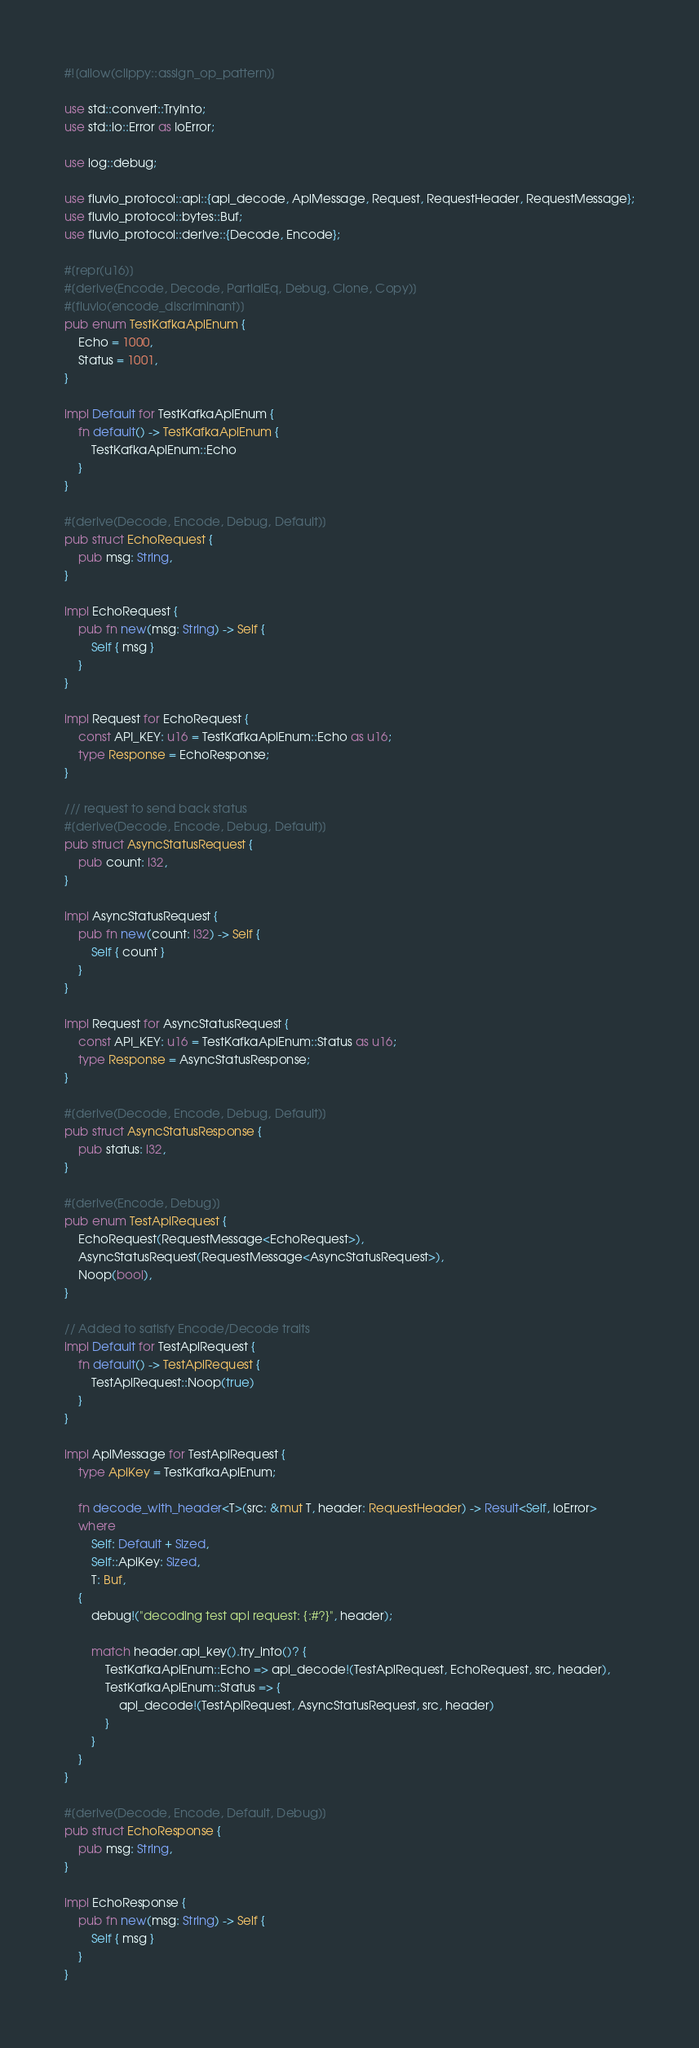Convert code to text. <code><loc_0><loc_0><loc_500><loc_500><_Rust_>#![allow(clippy::assign_op_pattern)]

use std::convert::TryInto;
use std::io::Error as IoError;

use log::debug;

use fluvio_protocol::api::{api_decode, ApiMessage, Request, RequestHeader, RequestMessage};
use fluvio_protocol::bytes::Buf;
use fluvio_protocol::derive::{Decode, Encode};

#[repr(u16)]
#[derive(Encode, Decode, PartialEq, Debug, Clone, Copy)]
#[fluvio(encode_discriminant)]
pub enum TestKafkaApiEnum {
    Echo = 1000,
    Status = 1001,
}

impl Default for TestKafkaApiEnum {
    fn default() -> TestKafkaApiEnum {
        TestKafkaApiEnum::Echo
    }
}

#[derive(Decode, Encode, Debug, Default)]
pub struct EchoRequest {
    pub msg: String,
}

impl EchoRequest {
    pub fn new(msg: String) -> Self {
        Self { msg }
    }
}

impl Request for EchoRequest {
    const API_KEY: u16 = TestKafkaApiEnum::Echo as u16;
    type Response = EchoResponse;
}

/// request to send back status
#[derive(Decode, Encode, Debug, Default)]
pub struct AsyncStatusRequest {
    pub count: i32,
}

impl AsyncStatusRequest {
    pub fn new(count: i32) -> Self {
        Self { count }
    }
}

impl Request for AsyncStatusRequest {
    const API_KEY: u16 = TestKafkaApiEnum::Status as u16;
    type Response = AsyncStatusResponse;
}

#[derive(Decode, Encode, Debug, Default)]
pub struct AsyncStatusResponse {
    pub status: i32,
}

#[derive(Encode, Debug)]
pub enum TestApiRequest {
    EchoRequest(RequestMessage<EchoRequest>),
    AsyncStatusRequest(RequestMessage<AsyncStatusRequest>),
    Noop(bool),
}

// Added to satisfy Encode/Decode traits
impl Default for TestApiRequest {
    fn default() -> TestApiRequest {
        TestApiRequest::Noop(true)
    }
}

impl ApiMessage for TestApiRequest {
    type ApiKey = TestKafkaApiEnum;

    fn decode_with_header<T>(src: &mut T, header: RequestHeader) -> Result<Self, IoError>
    where
        Self: Default + Sized,
        Self::ApiKey: Sized,
        T: Buf,
    {
        debug!("decoding test api request: {:#?}", header);

        match header.api_key().try_into()? {
            TestKafkaApiEnum::Echo => api_decode!(TestApiRequest, EchoRequest, src, header),
            TestKafkaApiEnum::Status => {
                api_decode!(TestApiRequest, AsyncStatusRequest, src, header)
            }
        }
    }
}

#[derive(Decode, Encode, Default, Debug)]
pub struct EchoResponse {
    pub msg: String,
}

impl EchoResponse {
    pub fn new(msg: String) -> Self {
        Self { msg }
    }
}
</code> 